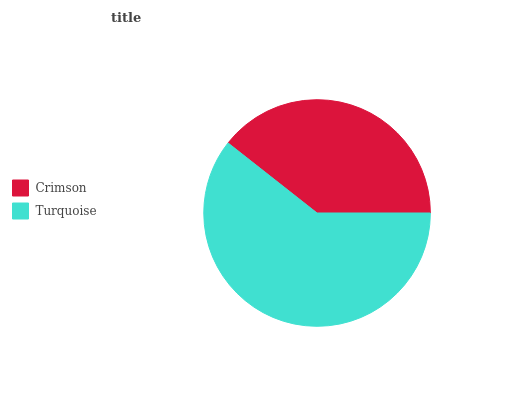Is Crimson the minimum?
Answer yes or no. Yes. Is Turquoise the maximum?
Answer yes or no. Yes. Is Turquoise the minimum?
Answer yes or no. No. Is Turquoise greater than Crimson?
Answer yes or no. Yes. Is Crimson less than Turquoise?
Answer yes or no. Yes. Is Crimson greater than Turquoise?
Answer yes or no. No. Is Turquoise less than Crimson?
Answer yes or no. No. Is Turquoise the high median?
Answer yes or no. Yes. Is Crimson the low median?
Answer yes or no. Yes. Is Crimson the high median?
Answer yes or no. No. Is Turquoise the low median?
Answer yes or no. No. 